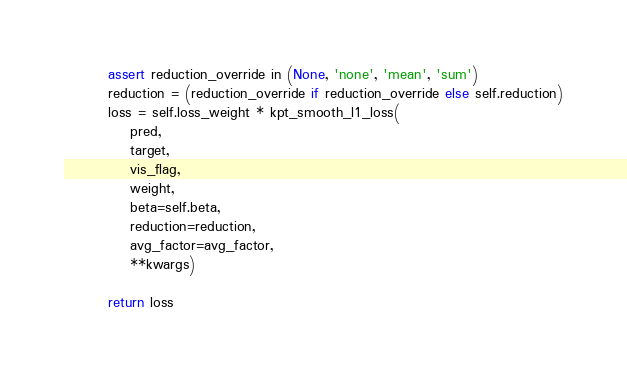Convert code to text. <code><loc_0><loc_0><loc_500><loc_500><_Python_>        assert reduction_override in (None, 'none', 'mean', 'sum')
        reduction = (reduction_override if reduction_override else self.reduction)
        loss = self.loss_weight * kpt_smooth_l1_loss(
            pred,
            target,
            vis_flag, 
            weight,
            beta=self.beta,
            reduction=reduction,
            avg_factor=avg_factor,
            **kwargs)
        
        return loss</code> 